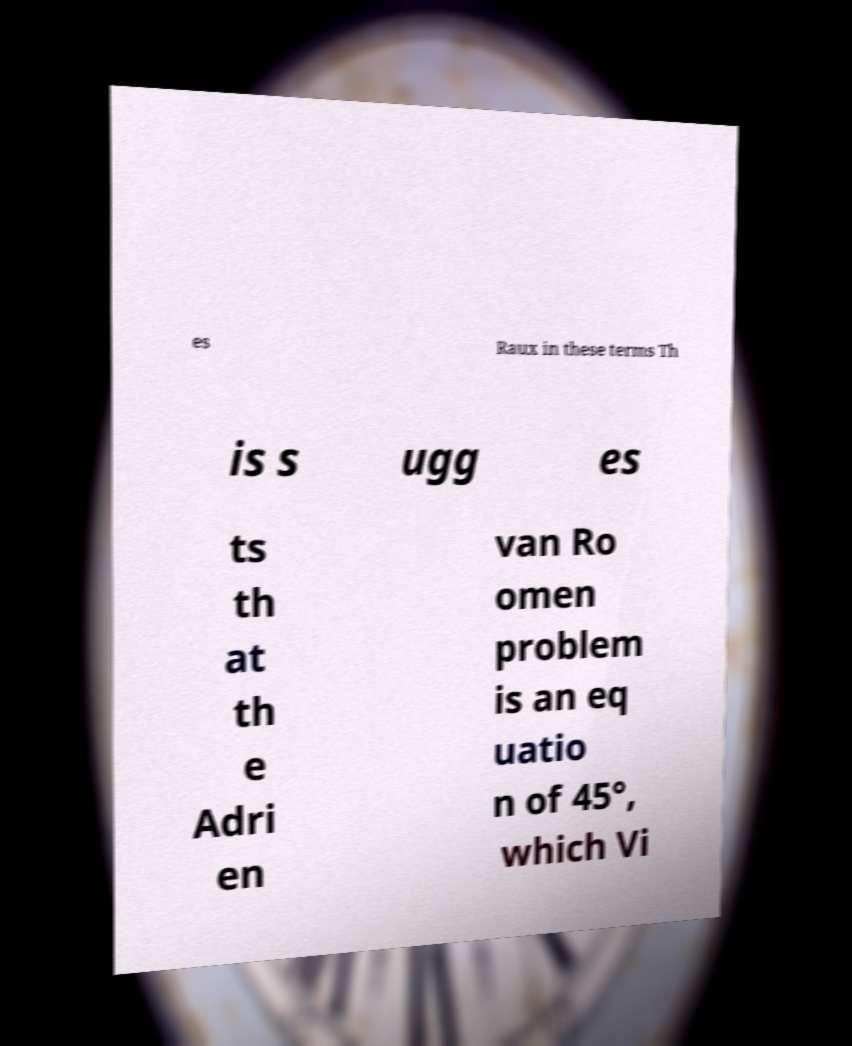What messages or text are displayed in this image? I need them in a readable, typed format. es Raux in these terms Th is s ugg es ts th at th e Adri en van Ro omen problem is an eq uatio n of 45°, which Vi 